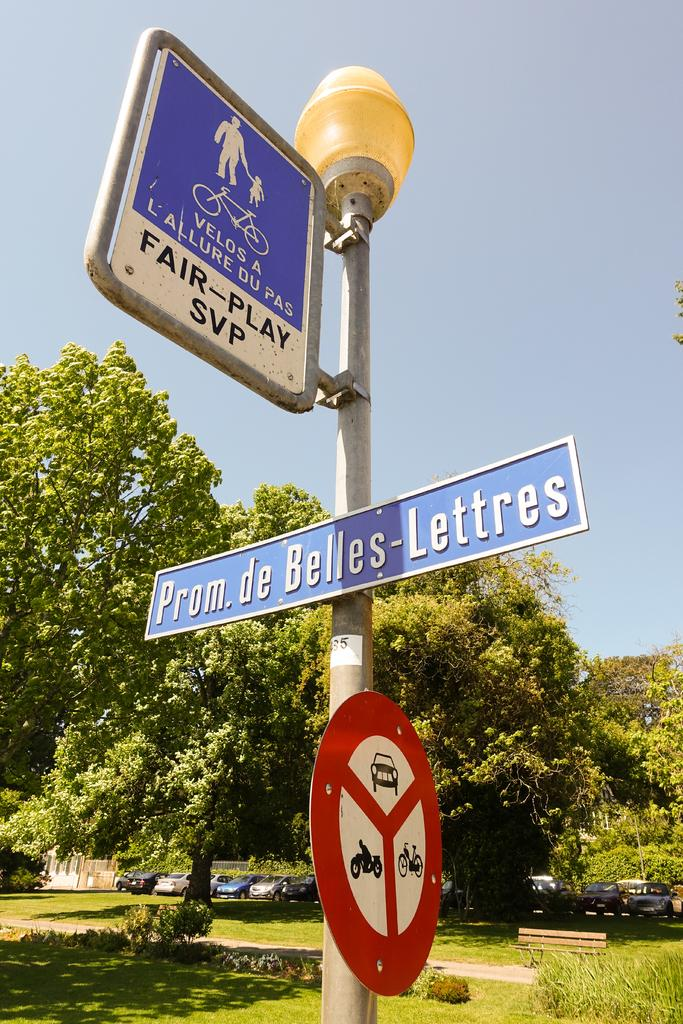What is the main object in the image? There is a lamp post in the image. Are there any additional features on the lamp post? Yes, there are sign boards attached to the lamp post. What can be seen in the background of the image? Trees and grass are visible in the background of the image. What type of silk is being used to make the police can in the image? There is no silk, police, or can present in the image. 